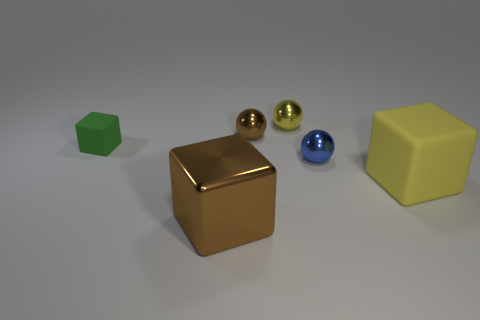Subtract all tiny blue shiny spheres. How many spheres are left? 2 Subtract all yellow blocks. How many blocks are left? 2 Subtract 3 spheres. How many spheres are left? 0 Add 4 cubes. How many objects exist? 10 Subtract all cyan cubes. How many blue balls are left? 1 Add 4 small yellow objects. How many small yellow objects are left? 5 Add 5 large balls. How many large balls exist? 5 Subtract 0 red cylinders. How many objects are left? 6 Subtract all blue spheres. Subtract all yellow cylinders. How many spheres are left? 2 Subtract all tiny purple cylinders. Subtract all blue objects. How many objects are left? 5 